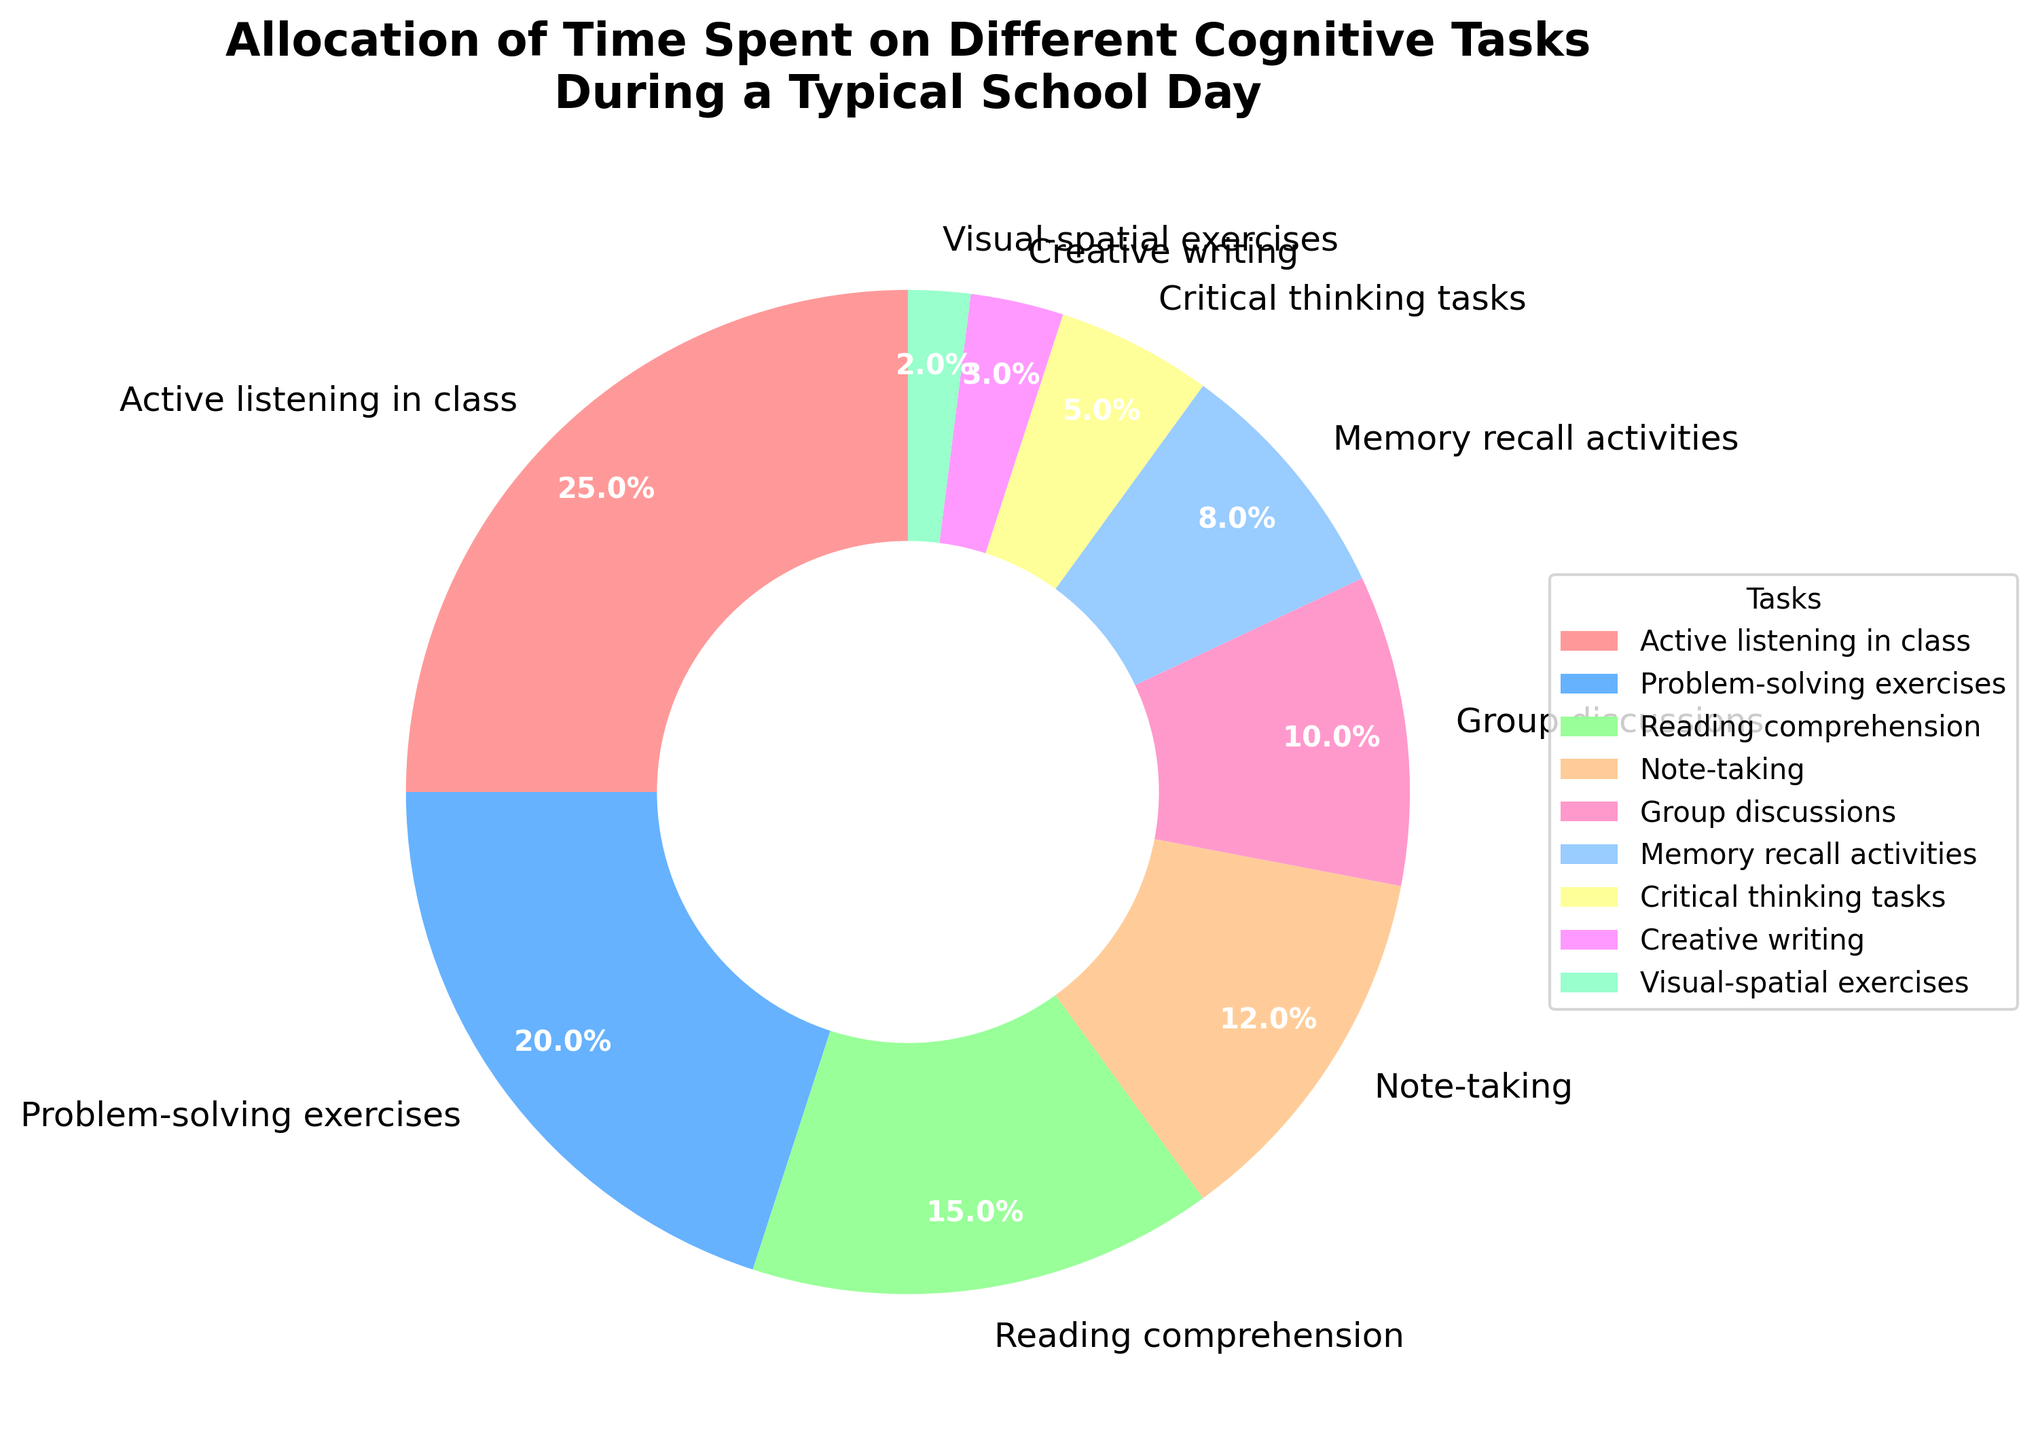Which task takes up the most time during a typical school day, and what percentage of time is allocated to it? The task with the highest percentage on the pie chart represents the one that takes up the most time. According to the chart, "Active listening in class" is the task with the highest percentage.
Answer: Active listening in class, 25% What is the combined percentage of time spent on Problem-solving exercises and Reading comprehension? To find the combined percentage, add the percentages for "Problem-solving exercises" and "Reading comprehension": 20% + 15%.
Answer: 35% Which task has the smallest allocation of time, and what percentage is allocated to it? The task with the smallest allocation is the one with the smallest slice in the pie chart. According to the chart, "Visual-spatial exercises" has the smallest allocation.
Answer: Visual-spatial exercises, 2% How much more time is allocated to Group discussions compared to Creative writing? To find the difference, subtract the percentage of time allocated to "Creative writing" from that allocated to "Group discussions": 10% - 3%.
Answer: 7% Is the time allocated to Note-taking higher or lower than the time allocated to Memory recall activities, and by how much? Compare the percentages for "Note-taking" and "Memory recall activities". Note-taking is 12% and Memory recall activities is 8%. Subtract the smaller from the larger: 12% - 8%.
Answer: Higher by 4% What is the total percentage of time spent on Critical thinking tasks and Visual-spatial exercises combined? To find the total, add the percentages for "Critical thinking tasks" and "Visual-spatial exercises": 5% + 2%.
Answer: 7% Are there any tasks that have the same percentage of time allocation, and if so, which ones? Scan the pie chart to check if any two tasks have the same percentage. In this case, no two tasks have the same percentage.
Answer: No Which task uses a green-colored slice, and what percentage is allocated to it? Identify the green-colored slice on the pie chart. According to the given colors, "Reading comprehension" uses a green-colored slice.
Answer: Reading comprehension, 15% What is the percentage of time allocated to tasks other than Active listening in class, Problem-solving exercises, and Reading comprehension? Subtract the combined percentage of the mentioned tasks from 100%: 100% - (25% + 20% + 15%).
Answer: 40% If the time allocated to Memory recall activities were doubled, what would the new percentage be, and would it become the highest allocation? Doubling the percentage of Memory recall activities: 8% * 2 = 16%. Compare it with the highest existing percentage, which is 25% for Active listening.
Answer: 16%, No 